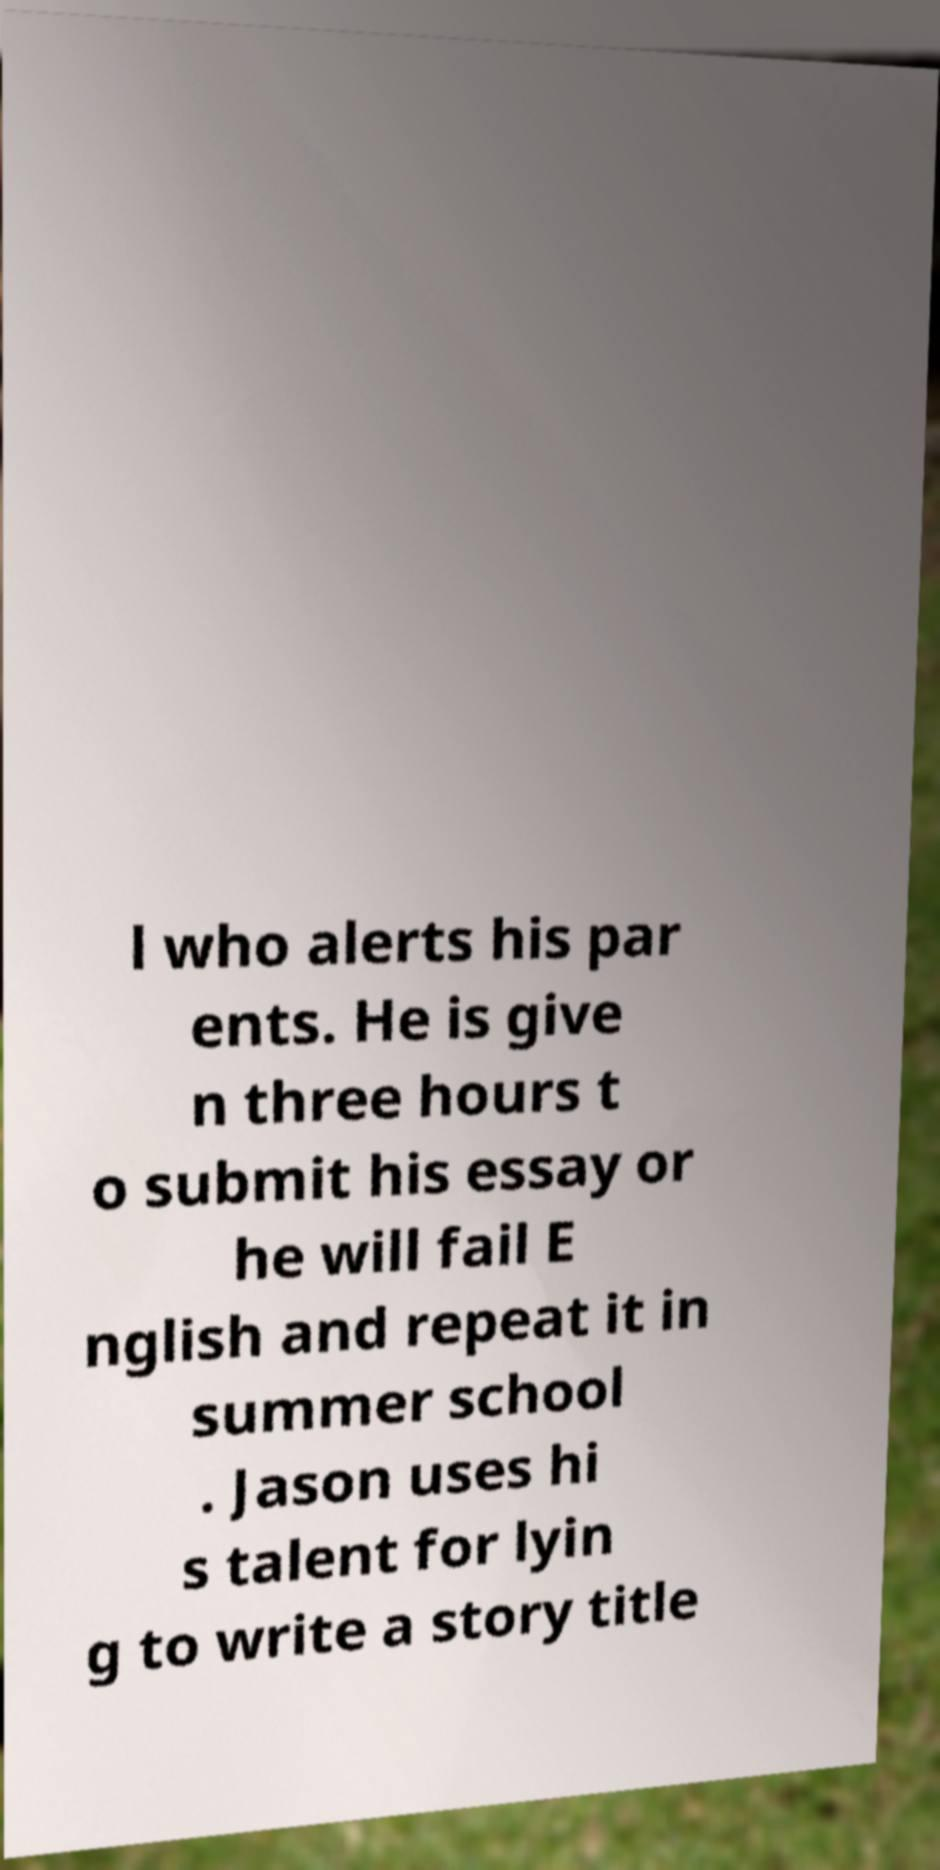Can you read and provide the text displayed in the image?This photo seems to have some interesting text. Can you extract and type it out for me? l who alerts his par ents. He is give n three hours t o submit his essay or he will fail E nglish and repeat it in summer school . Jason uses hi s talent for lyin g to write a story title 